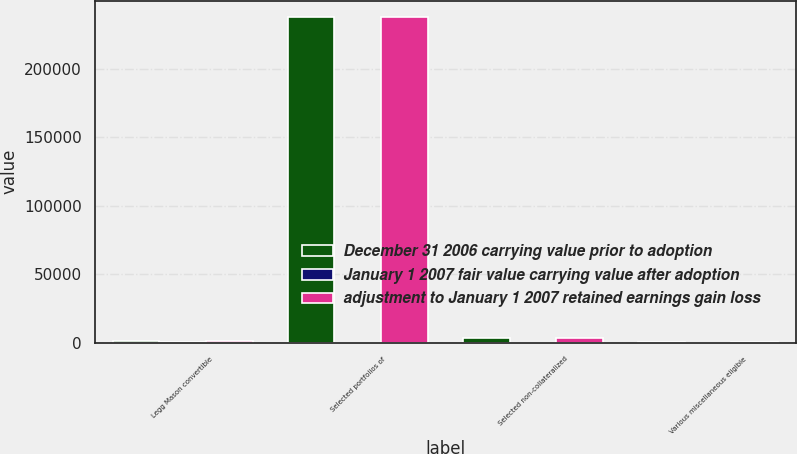Convert chart to OTSL. <chart><loc_0><loc_0><loc_500><loc_500><stacked_bar_chart><ecel><fcel>Legg Mason convertible<fcel>Selected portfolios of<fcel>Selected non-collateralized<fcel>Various miscellaneous eligible<nl><fcel>December 31 2006 carrying value prior to adoption<fcel>797<fcel>237788<fcel>3284<fcel>96<nl><fcel>January 1 2007 fair value carrying value after adoption<fcel>232<fcel>40<fcel>7<fcel>3<nl><fcel>adjustment to January 1 2007 retained earnings gain loss<fcel>797<fcel>237748<fcel>3291<fcel>96<nl></chart> 